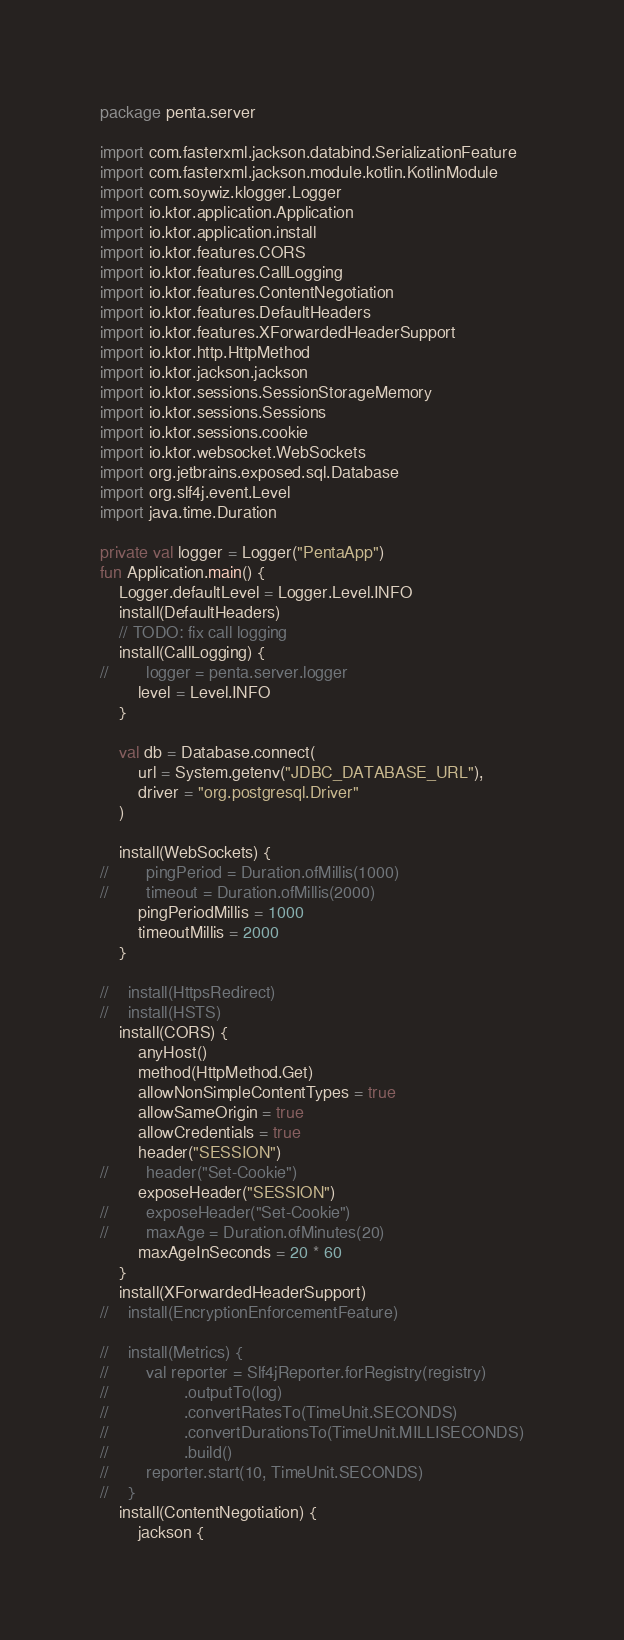Convert code to text. <code><loc_0><loc_0><loc_500><loc_500><_Kotlin_>package penta.server

import com.fasterxml.jackson.databind.SerializationFeature
import com.fasterxml.jackson.module.kotlin.KotlinModule
import com.soywiz.klogger.Logger
import io.ktor.application.Application
import io.ktor.application.install
import io.ktor.features.CORS
import io.ktor.features.CallLogging
import io.ktor.features.ContentNegotiation
import io.ktor.features.DefaultHeaders
import io.ktor.features.XForwardedHeaderSupport
import io.ktor.http.HttpMethod
import io.ktor.jackson.jackson
import io.ktor.sessions.SessionStorageMemory
import io.ktor.sessions.Sessions
import io.ktor.sessions.cookie
import io.ktor.websocket.WebSockets
import org.jetbrains.exposed.sql.Database
import org.slf4j.event.Level
import java.time.Duration

private val logger = Logger("PentaApp")
fun Application.main() {
    Logger.defaultLevel = Logger.Level.INFO
    install(DefaultHeaders)
    // TODO: fix call logging
    install(CallLogging) {
//        logger = penta.server.logger
        level = Level.INFO
    }

    val db = Database.connect(
        url = System.getenv("JDBC_DATABASE_URL"),
        driver = "org.postgresql.Driver"
    )

    install(WebSockets) {
//        pingPeriod = Duration.ofMillis(1000)
//        timeout = Duration.ofMillis(2000)
        pingPeriodMillis = 1000
        timeoutMillis = 2000
    }

//    install(HttpsRedirect)
//    install(HSTS)
    install(CORS) {
        anyHost()
        method(HttpMethod.Get)
        allowNonSimpleContentTypes = true
        allowSameOrigin = true
        allowCredentials = true
        header("SESSION")
//        header("Set-Cookie")
        exposeHeader("SESSION")
//        exposeHeader("Set-Cookie")
//        maxAge = Duration.ofMinutes(20)
        maxAgeInSeconds = 20 * 60
    }
    install(XForwardedHeaderSupport)
//    install(EncryptionEnforcementFeature)

//    install(Metrics) {
//        val reporter = Slf4jReporter.forRegistry(registry)
//                .outputTo(log)
//                .convertRatesTo(TimeUnit.SECONDS)
//                .convertDurationsTo(TimeUnit.MILLISECONDS)
//                .build()
//        reporter.start(10, TimeUnit.SECONDS)
//    }
    install(ContentNegotiation) {
        jackson {</code> 